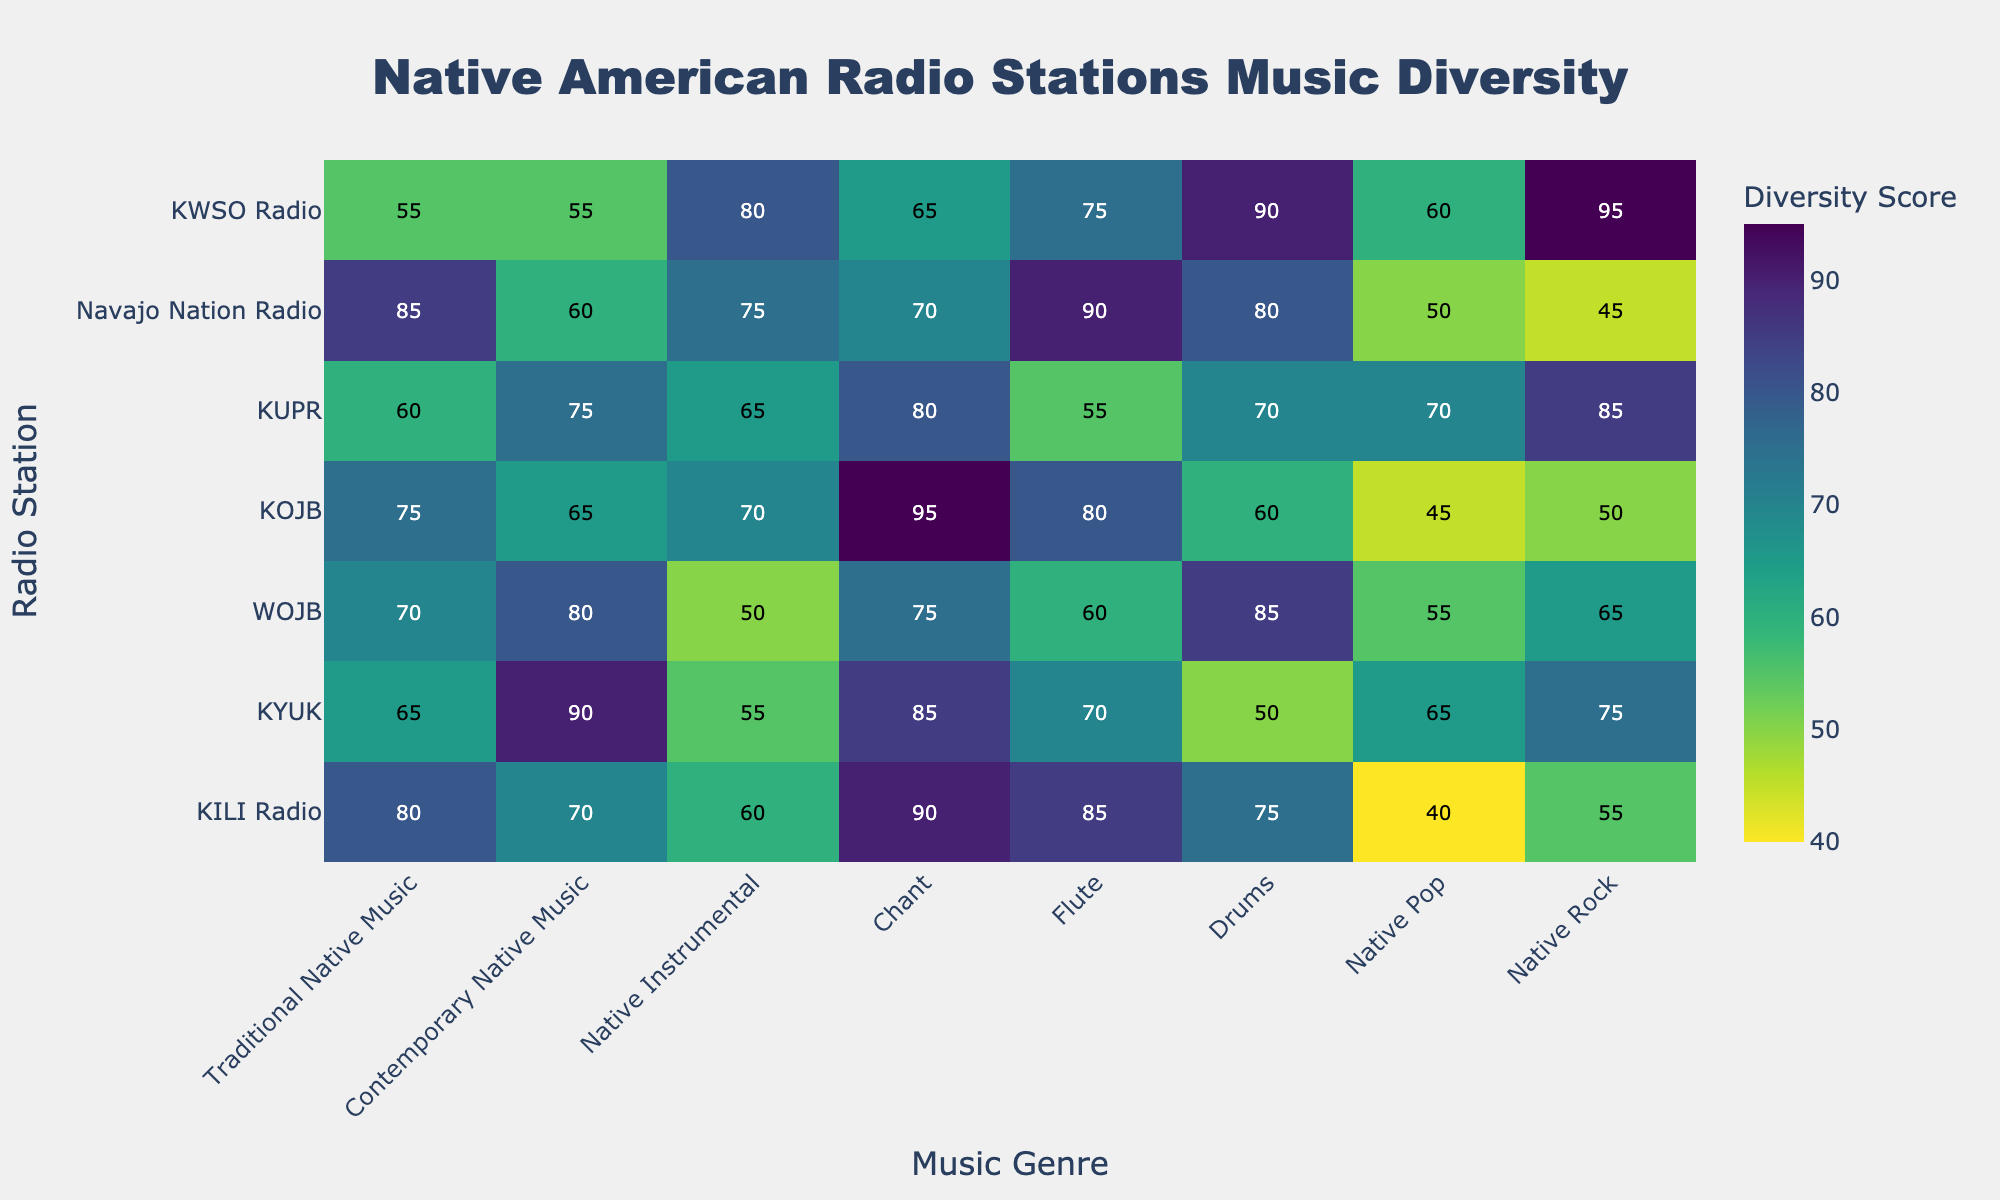What is the title of the heatmap? Looking at the top of the heatmap, the title is prominently displayed in a large font.
Answer: Native American Radio Stations Music Diversity Which radio station has the highest diversity score for Traditional Native Music? Find the column labeled "Traditional Native Music" and look for the highest value. The highest value is 85 for "Navajo Nation Radio".
Answer: Navajo Nation Radio How many genres have a diversity score below 60 for KILI Radio? Search for the row titled "KILI Radio" and count the number of values less than 60. The values are 40 and 55 (in "Native Pop" and "Native Rock", respectively).
Answer: 2 What is the average diversity score for Contemporary Native Music across all radio stations? Add the diversity scores for "Contemporary Native Music" column (70 + 90 + 80 + 65 + 75 + 60 + 55) and divide by the number of stations, which is 7.
Answer: 70.71 Which radio station broadcasts the most diverse music based on their lowest diversity score? Identify the lowest diversity score for each radio station and compare them. "KILI Radio" has 40 as the minimum score which is the lowest among all stations.
Answer: KILI Radio Are there any radio stations with a diversity score of 95? Scan the entire heatmap for the value 95. KOJB has 95 in the "Chant" genre, and KWSO Radio has 95 in "Native Rock".
Answer: Yes Which music genre has the least variability in diversity scores across radio stations? Calculate the range of scores (maximum - minimum) for each genre and find the genre with the smallest range. "Flute" scores range from 55 to 90, giving a range of 35, which is the smallest discovered.
Answer: Flute What is the total diversity score for Drums across all radio stations? Sum the values of the "Drums" column for all radio stations (75 + 50 + 85 + 60 + 70 + 80 + 90).
Answer: 510 